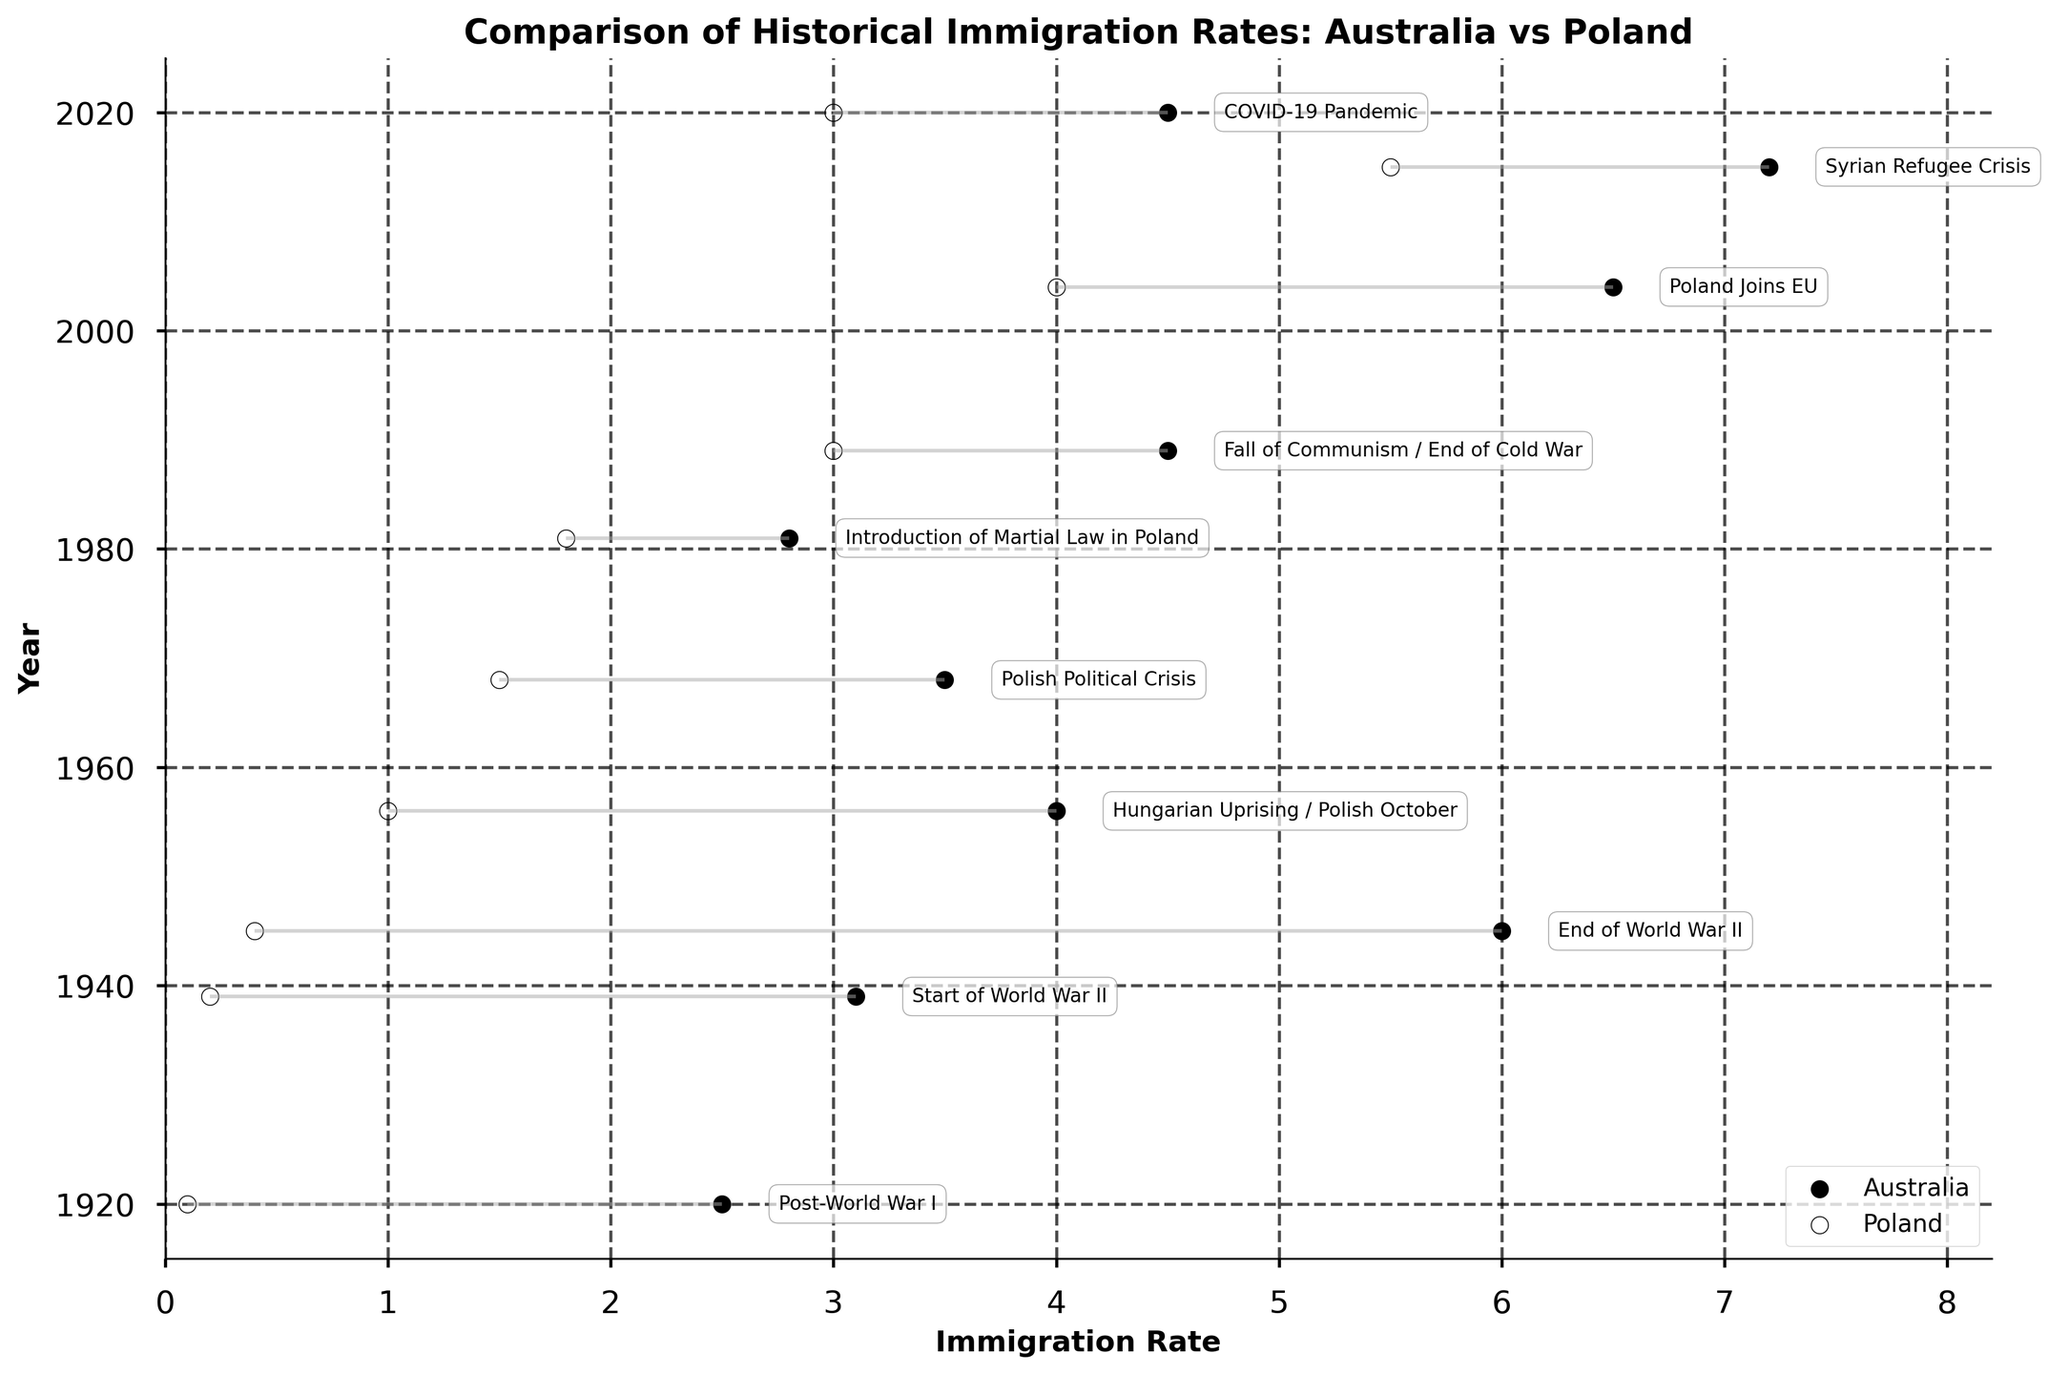what is the title of the plot? The title of the plot is usually located at the top of the figure. In the provided figure, the title is 'Comparison of Historical Immigration Rates: Australia vs Poland'.
Answer: 'Comparison of Historical Immigration Rates: Australia vs Poland' which country had a higher immigration rate in 1945? We need to compare the immigration rates of Australia and Poland in the year 1945. According to the data, Australia's immigration rate was 6.0, whereas Poland's was 0.4. Therefore, Australia had a higher immigration rate in 1945.
Answer: Australia how many years are represented in the plot? We can determine the number of years by counting the different points on the y-axis. Each point represents a year. The provided data lists the years 1920, 1939, 1945, 1956, 1968, 1981, 1989, 2004, 2015, and 2020, totaling 10 years.
Answer: 10 which event corresponds to the highest immigration rate for Poland? To find the event corresponding to the highest immigration rate for Poland, we look for the highest value in the Poland_Immigration_Rate column. The highest value is 5.5, which corresponds to the year 2015, during the Syrian Refugee Crisis.
Answer: Syrian Refugee Crisis what is the difference in immigration rate between Australia and Poland in 1989? In 1989, the immigration rate for Australia was 4.5, and for Poland, it was 3.0. By subtracting Poland's rate from Australia's rate, we get 4.5 - 3.0 = 1.5.
Answer: 1.5 which country shows a greater change in immigration rate from 1920 to 2020? To find the country with the greater change in immigration rate, we need to calculate the difference in immigration rates for each country from 1920 to 2020. For Australia, the change is 4.5 - 2.5 = 2.0. For Poland, the change is 3.0 - 0.1 = 2.9. Therefore, Poland shows a greater change.
Answer: Poland during which event did the immigration rate in Australia decrease compared to the previous point on the plot? We need to look for a point where Australia's immigration rate is lower than the previous point. The immigration rate drops from 6.0 in 1945 to 4.0 in 1956, corresponding to the Hungarian Uprising / Polish October event.
Answer: Hungarian Uprising / Polish October at which year were the immigration rates of both countries equal? We need to find a year where both immigration rates are the same. Based on the data, there is no year where the immigration rates of Australia and Poland are exactly equal.
Answer: None 